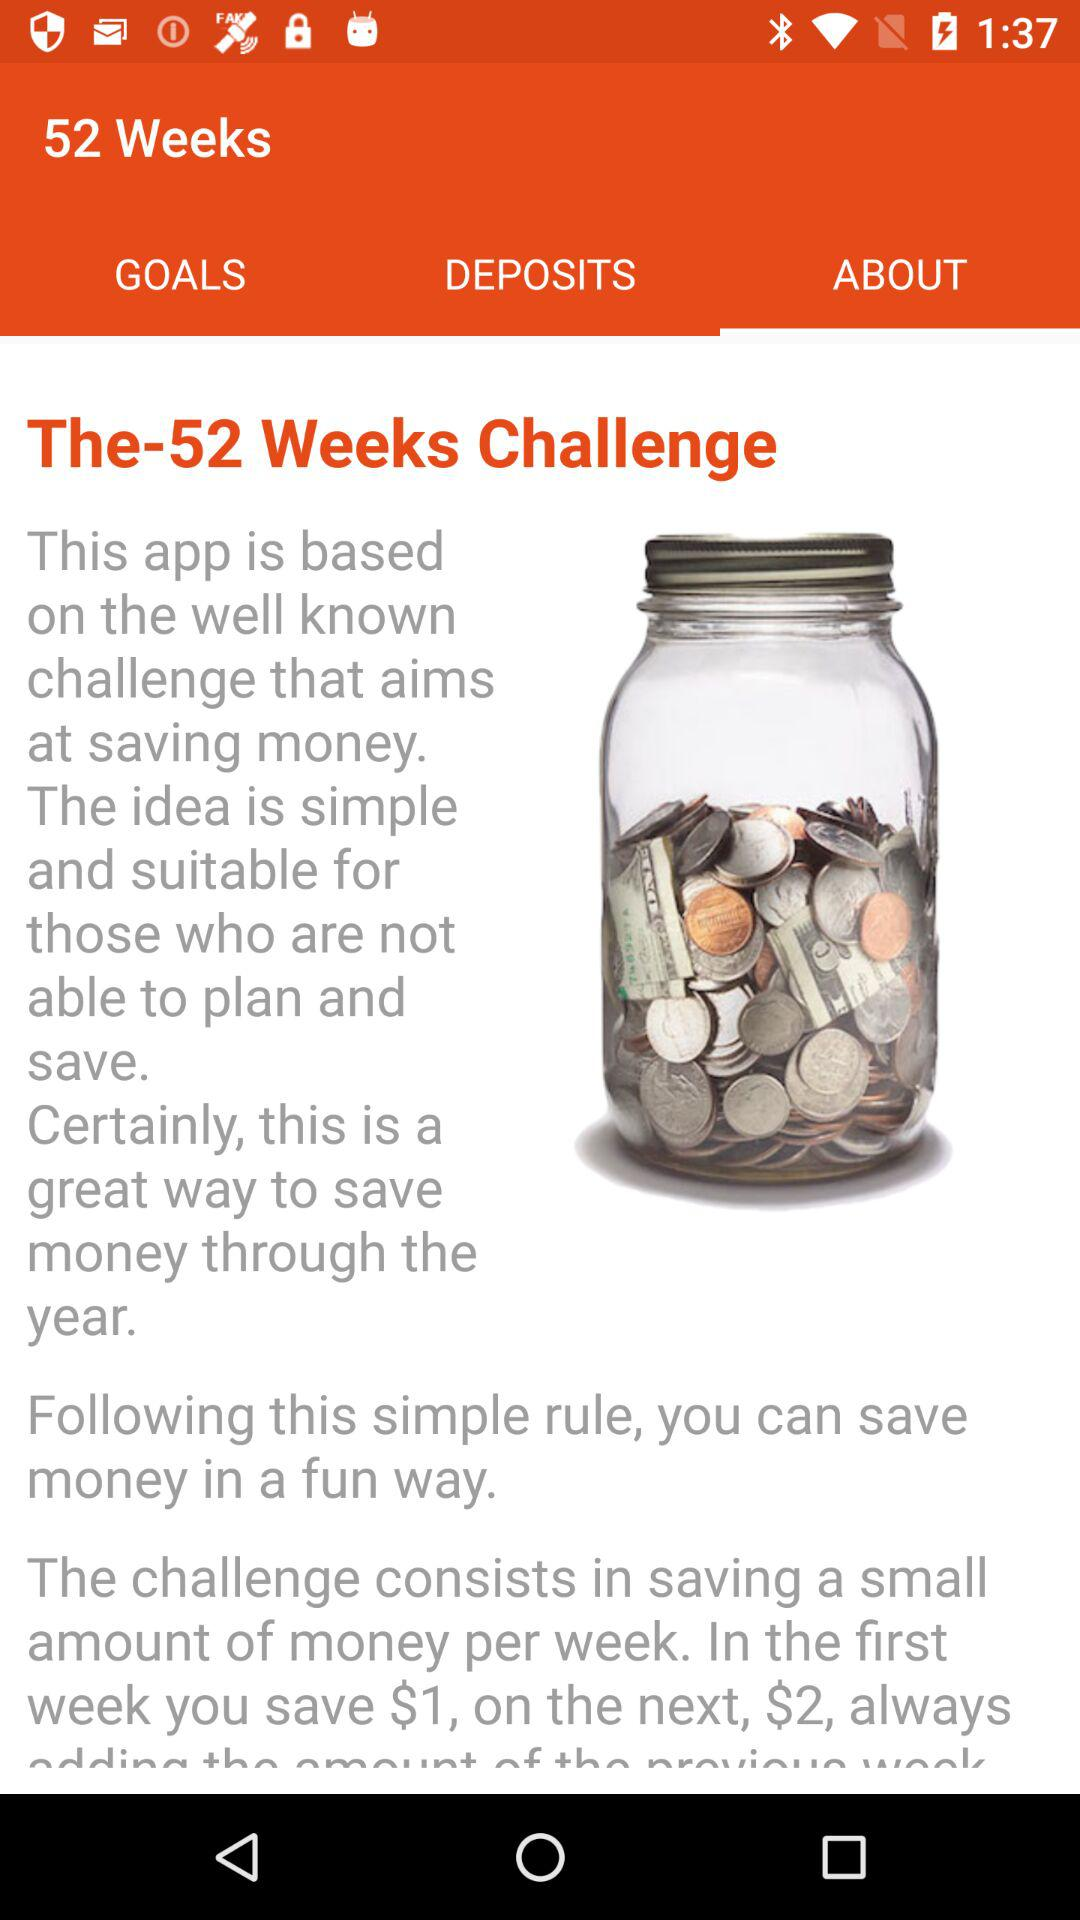What is "The-52 Weeks Challenge"? It is an "app is based on the well known challenge that aims at saving money. The idea is simple and suitable for those who are not able to plan and save. Certainly, this is a great way to save money through the year. Following this simple rule, you can save money in a fun way. The challenge consists in saving a small amount of money per week. In the first week you save $1, on the next, $2, always". 